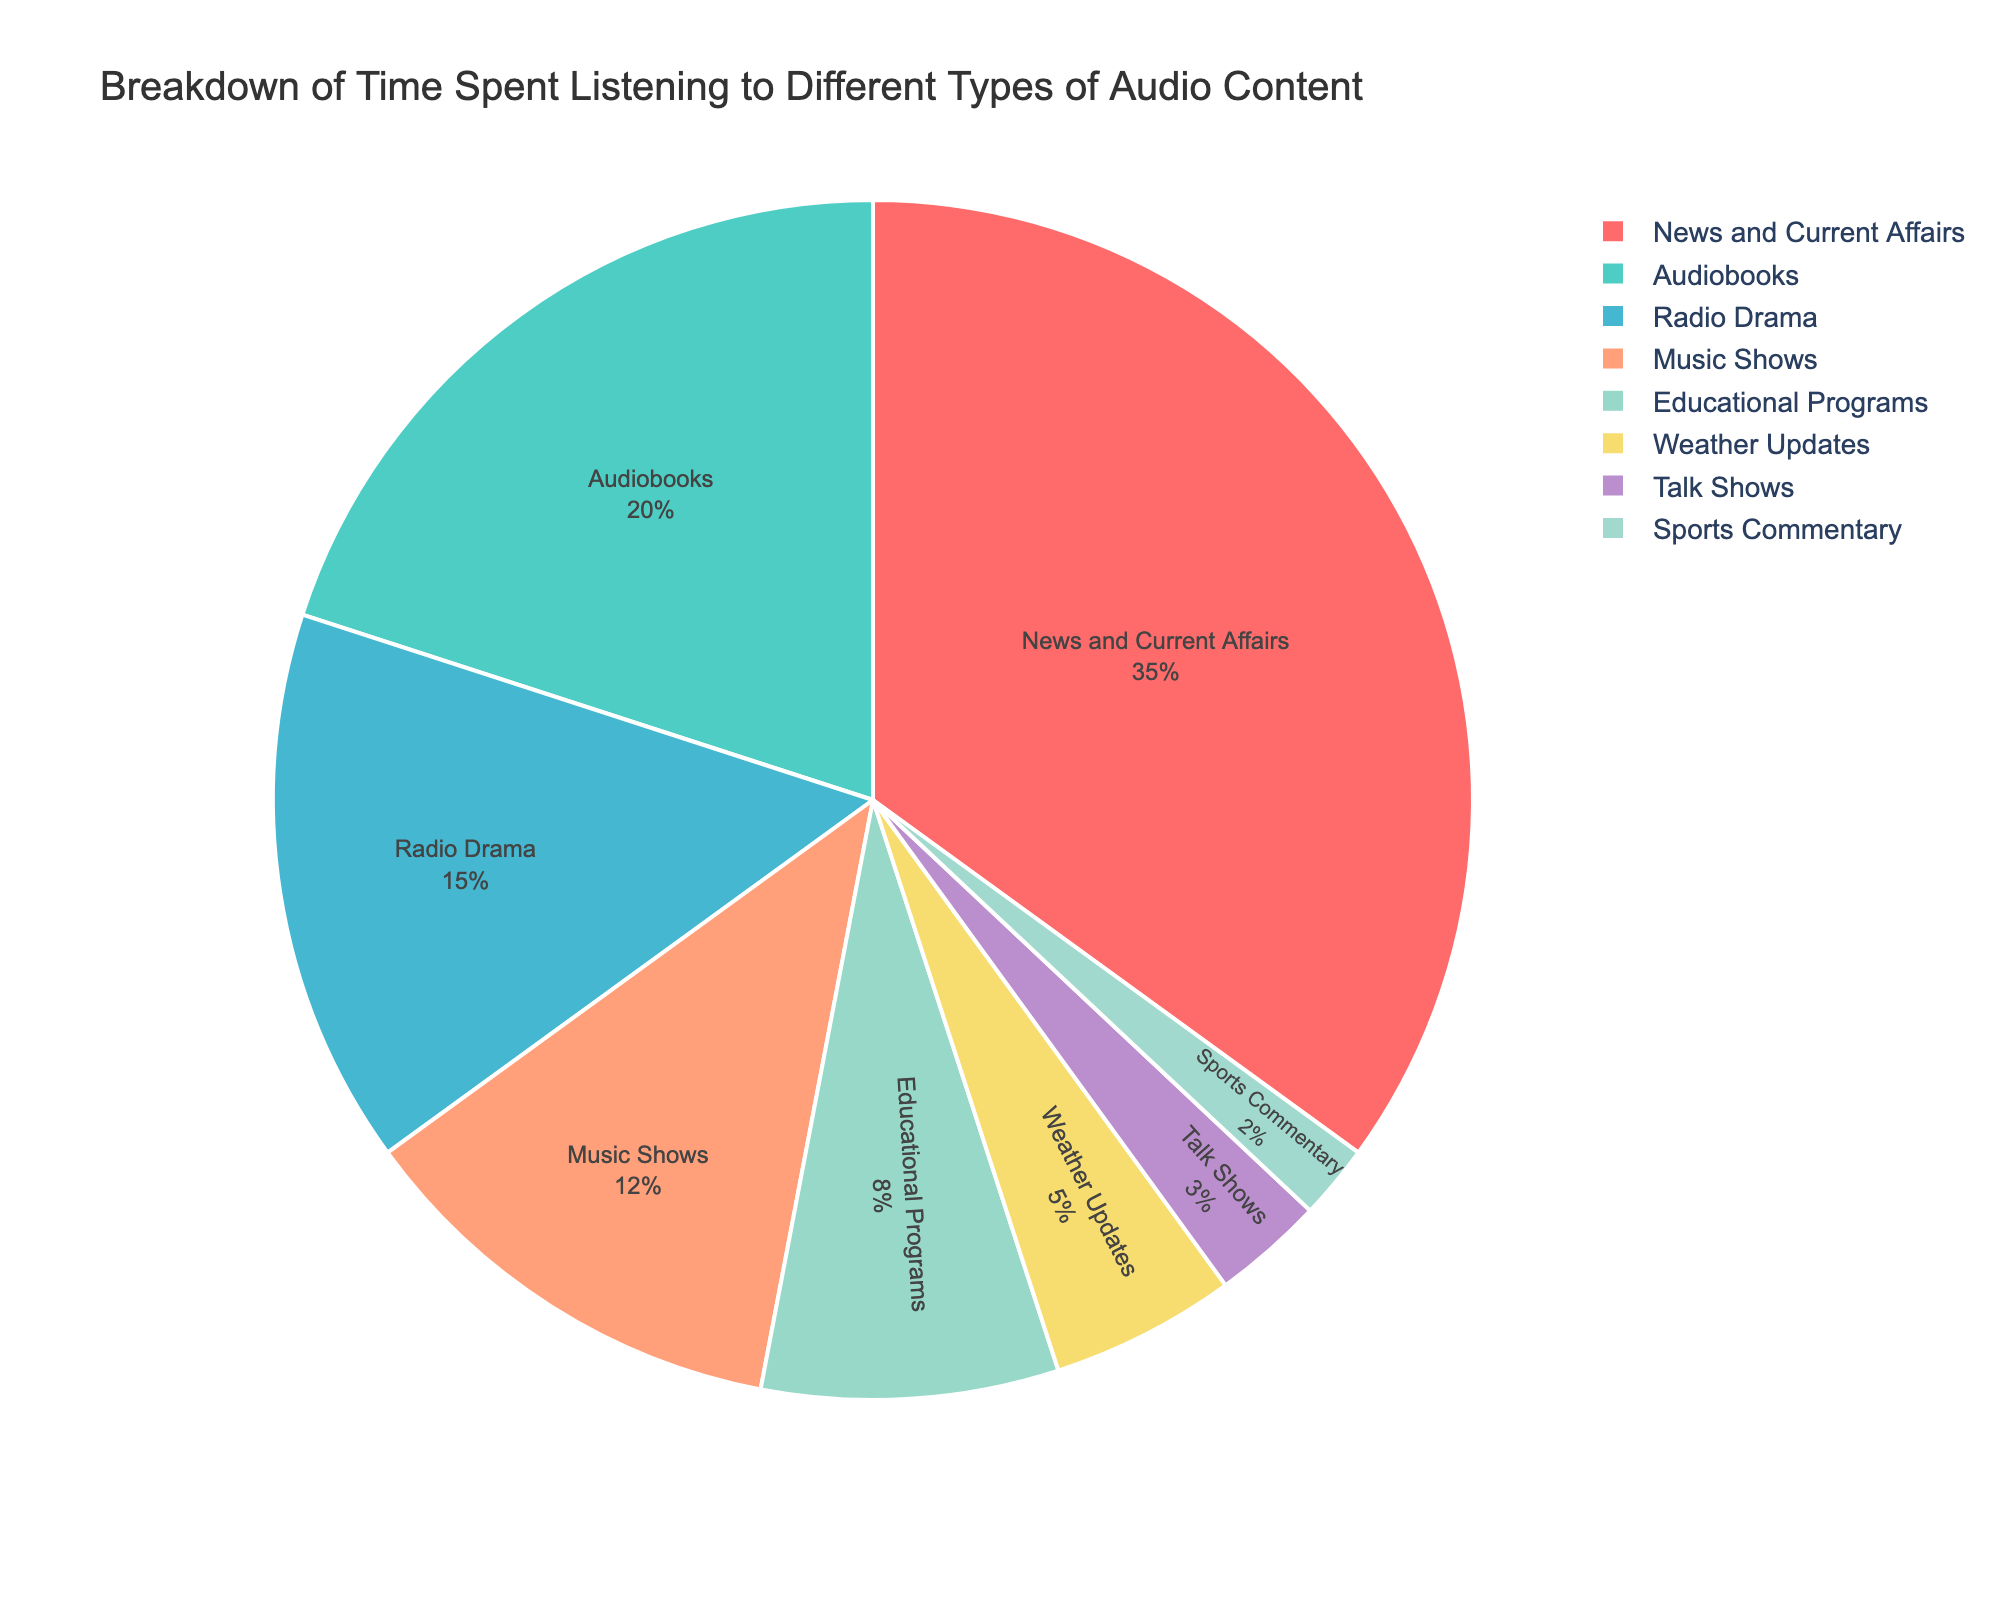What percentage of time is spent on News and Current Affairs? From the figure, it shows that News and Current Affairs account for a specific percentage of the total time.
Answer: 35% Which type of audio content takes up the least amount of time? The figure depicts various segments with their respective percentages. The smallest segment represents the least amount of time spent on a particular activity.
Answer: Sports Commentary (2%) How much more time is spent on News and Current Affairs compared to Sports Commentary? To find this, we need to subtract the percentage of time spent on Sports Commentary from the percentage of time spent on News and Current Affairs. \(35\% - 2\% = 33\% \)
Answer: 33% Are Music Shows listened to more than Educational Programs? We compare the percentages associated with Music Shows and Educational Programs.
Answer: Yes Which two types of audio content together make up more than half of the listening time? We need to look for two segments whose combined percentage exceeds 50%. News and Current Affairs (35%) and Audiobooks (20%) together account for \(35\% + 20\% = 55\%\).
Answer: News and Current Affairs and Audiobooks What is the difference in time spent listening to Radio Drama and Talk Shows? Subtract the percentage of time spent on Talk Shows from the percentage spent on Radio Drama. \(15\% - 3\% = 12\% \)
Answer: 12% Among the categories, which one is represented with the red color? The segments have distinctive colors, and we identify which one is red.
Answer: News and Current Affairs What percentage of time is dedicated to Educational Programs and Weather Updates combined? Sum the percentages for Educational Programs and Weather Updates. \(8\% + 5\% = 13\% \)
Answer: 13% List the content types in order of decreasing percentage. Arrange the labeled percentages in descending order.
Answer: News and Current Affairs (35%), Audiobooks (20%), Radio Drama (15%), Music Shows (12%), Educational Programs (8%), Weather Updates (5%), Talk Shows (3%), Sports Commentary (2%) Is the time spent on Talk Shows and Music Shows together more than the time spent on Audiobooks? Add the percentages for Talk Shows and Music Shows, then compare the sum to the percentage for Audiobooks. \(12\% + 3\% = 15\%\), which is less than 20%.
Answer: No 